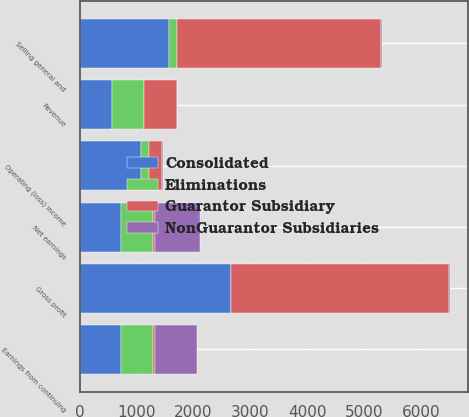Convert chart. <chart><loc_0><loc_0><loc_500><loc_500><stacked_bar_chart><ecel><fcel>Revenue<fcel>Gross profit<fcel>Selling general and<fcel>Operating (loss) income<fcel>Earnings from continuing<fcel>Net earnings<nl><fcel>NonGuarantor Subsidiaries<fcel>16<fcel>16<fcel>25<fcel>9<fcel>750<fcel>800<nl><fcel>Guarantor Subsidiary<fcel>567<fcel>3825<fcel>3587<fcel>238<fcel>28<fcel>28<nl><fcel>Consolidated<fcel>567<fcel>2649<fcel>1571<fcel>1078<fcel>723<fcel>723<nl><fcel>Eliminations<fcel>567<fcel>5<fcel>130<fcel>135<fcel>567<fcel>567<nl></chart> 